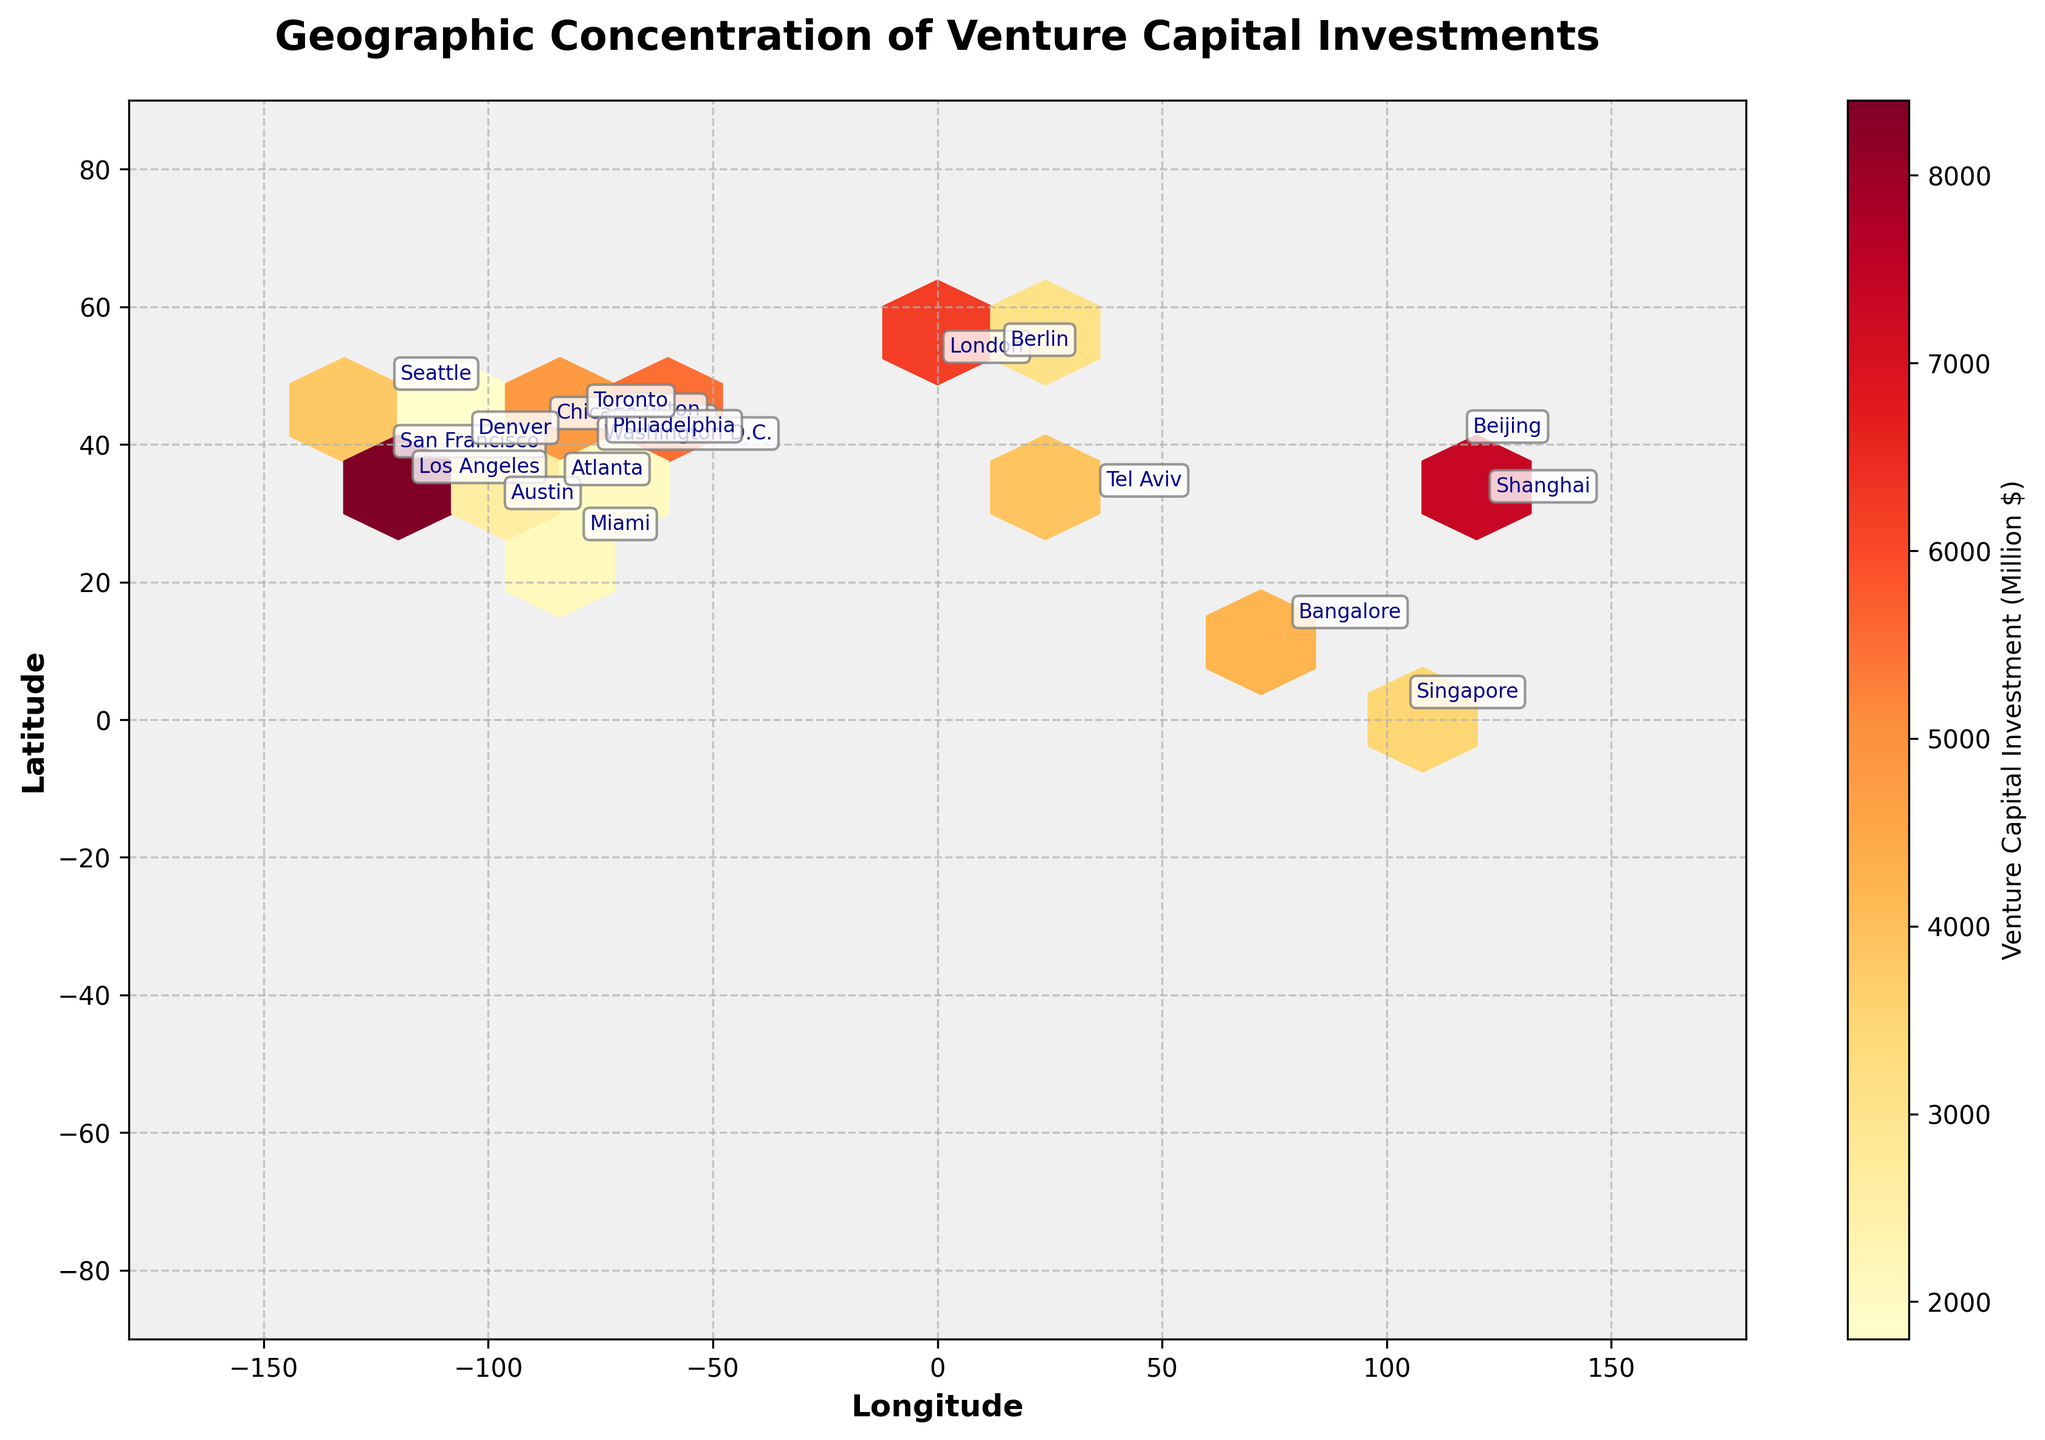What is the title of the plot? The title of the plot is displayed prominently at the top.
Answer: Geographic Concentration of Venture Capital Investments Which city has the highest Venture Capital Investment? Look for the city associated with the darkest color in the hexbin plot. In this figure, the city is annotated at the corresponding location.
Answer: San Francisco Which city appears to be closest in geographical location to New York? Check the latitude and longitude annotations to find the city closest to New York.
Answer: Philadelphia What is the color gradient used to represent the Venture Capital Investment? The color gradient is displayed in the color bar legend.
Answer: Yellow to Red How is Los Angeles' venture capital investment compared to Miami's? Check the annotations for Los Angeles and Miami, and observe the color intensity of each city's hexagon.
Answer: Los Angeles has a higher investment than Miami Which two cities in Europe have venture capital investments represented on the plot? Find the European geographical locations and respective city annotations.
Answer: London and Berlin What is the approximate geographical location of Beijing on the plot? Look for the coordinates near the annotation for Beijing.
Answer: Near latitude 39.9 and longitude 116.4 Which city is located at latitude 32.0853 and longitude 34.7818 and what is its venture capital investment? Cross-reference the latitude and longitude to find the city annotation and the corresponding venture capital investment.
Answer: Tel Aviv, $3900 Million How many cities on the plot have a venture capital investment greater than $5000 Million? Count the number of cities with colors darker than a certain threshold, indicating higher investment.
Answer: 4 cities (New York, San Francisco, Beijing, London) In which hemisphere does Singapore lie and what is its venture capital investment? Check the geographical location of Singapore in the southeast part of the plot and read the corresponding investment figure.
Answer: Southern Hemisphere, $3500 Million 